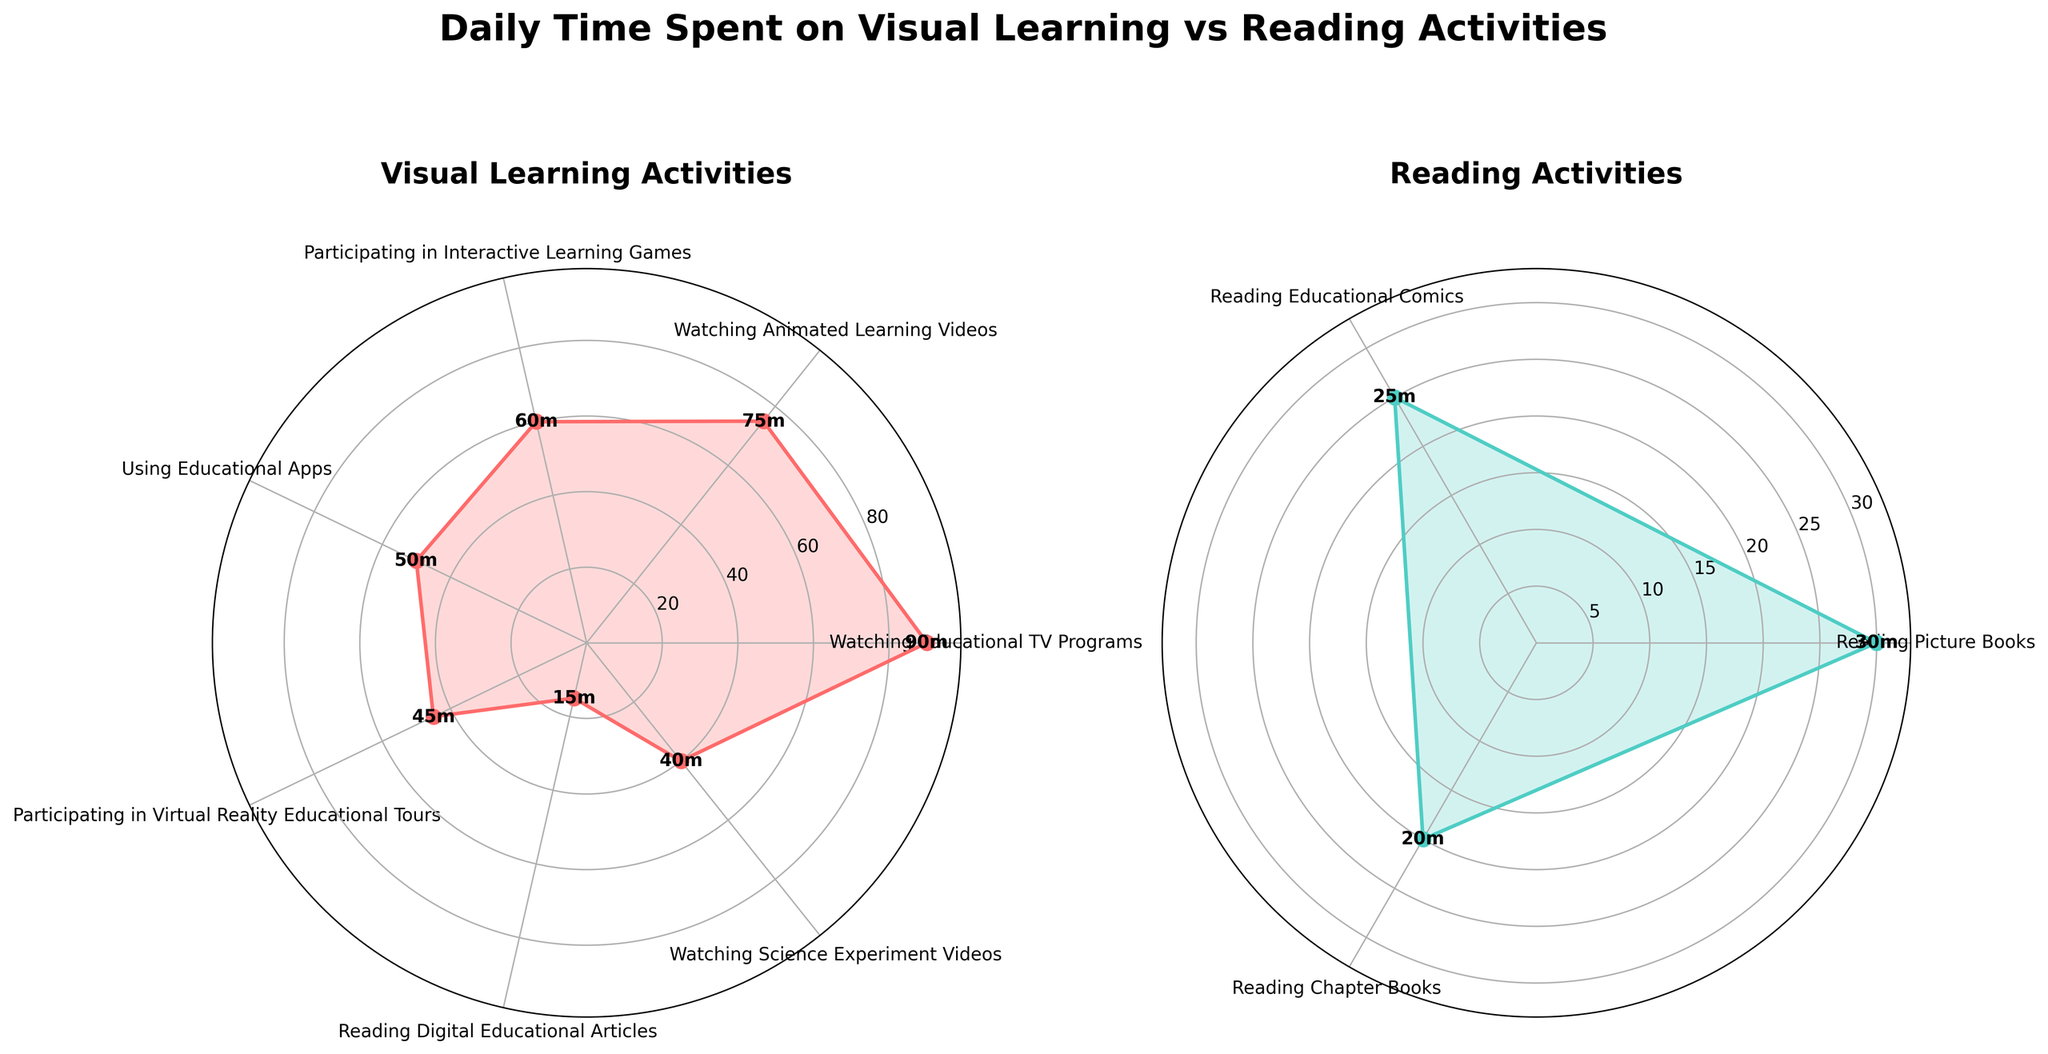What's the title of the figure? The title is displayed at the top center of the figure and reads "Daily Time Spent on Visual Learning vs Reading Activities".
Answer: "Daily Time Spent on Visual Learning vs Reading Activities" How many activities are included in the visual learning section? Count the number of labeled activities in the "Visual Learning Activities" rose chart. There are six activities listed.
Answer: 6 Which activity has the highest time spent in the reading activities section? By examining the labels in the "Reading Activities" rose chart and checking the corresponding time values, it is clear that "Reading Picture Books" has the highest time spent at 30 minutes.
Answer: Reading Picture Books What is the total time spent on reading activities? Add the time spent on each reading activity: 30 (Reading Picture Books) + 25 (Reading Educational Comics) + 20 (Reading Chapter Books) = 75 minutes.
Answer: 75 minutes What is the difference in the highest time spent between visual learning and reading activities? Identify the maximum time values from both sections: 90 minutes for "Watching Educational TV Programs" (visual) and 30 minutes for "Reading Picture Books" (reading). The difference is 90 - 30 = 60 minutes.
Answer: 60 minutes Which visual learning activity comes immediately after "Using Educational Apps" in the chart? By tracing the next label in the "Visual Learning Activities" rose chart after "Using Educational Apps", "Participating in Virtual Reality Educational Tours" is the next activity.
Answer: Participating in Virtual Reality Educational Tours What is the average time spent on the visual learning activities? Sum all the time values in the visual learning section and divide by the number of activities: (90 + 75 + 60 + 50 + 45 + 40) / 6 = 60 minutes.
Answer: 60 minutes What's the time difference between the highest and lowest time spent on visual learning activities? The highest time is 90 minutes ("Watching Educational TV Programs") and the lowest is 40 minutes ("Watching Science Experiment Videos"). The difference is 90 - 40 = 50 minutes.
Answer: 50 minutes Which color represents the reading activities in the figure? Observe the rose chart color shading for the "Reading Activities" section; it is represented by a turquoise-like color.
Answer: Turquoise 